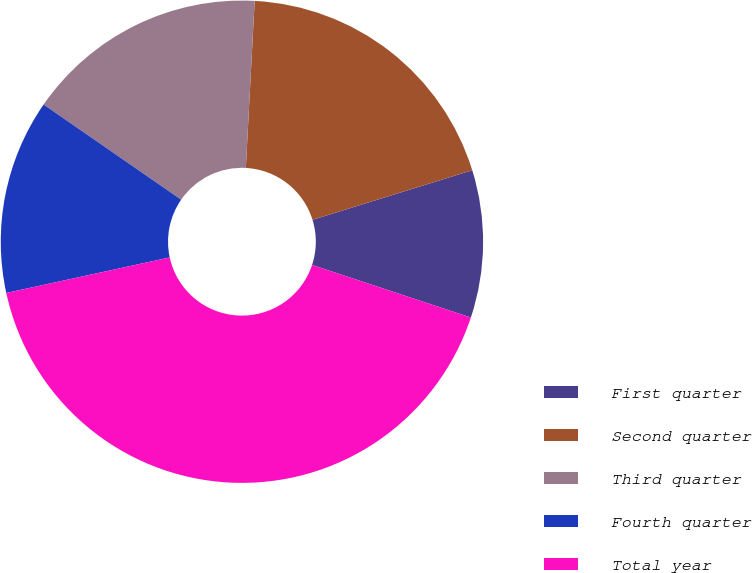Convert chart to OTSL. <chart><loc_0><loc_0><loc_500><loc_500><pie_chart><fcel>First quarter<fcel>Second quarter<fcel>Third quarter<fcel>Fourth quarter<fcel>Total year<nl><fcel>9.88%<fcel>19.37%<fcel>16.21%<fcel>13.04%<fcel>41.5%<nl></chart> 